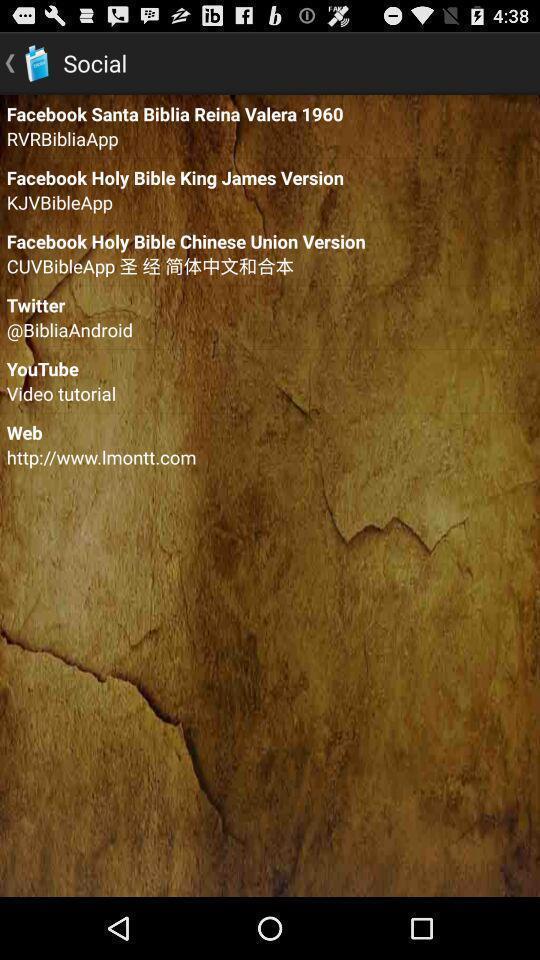Summarize the information in this screenshot. Screen displaying contents in social page. 